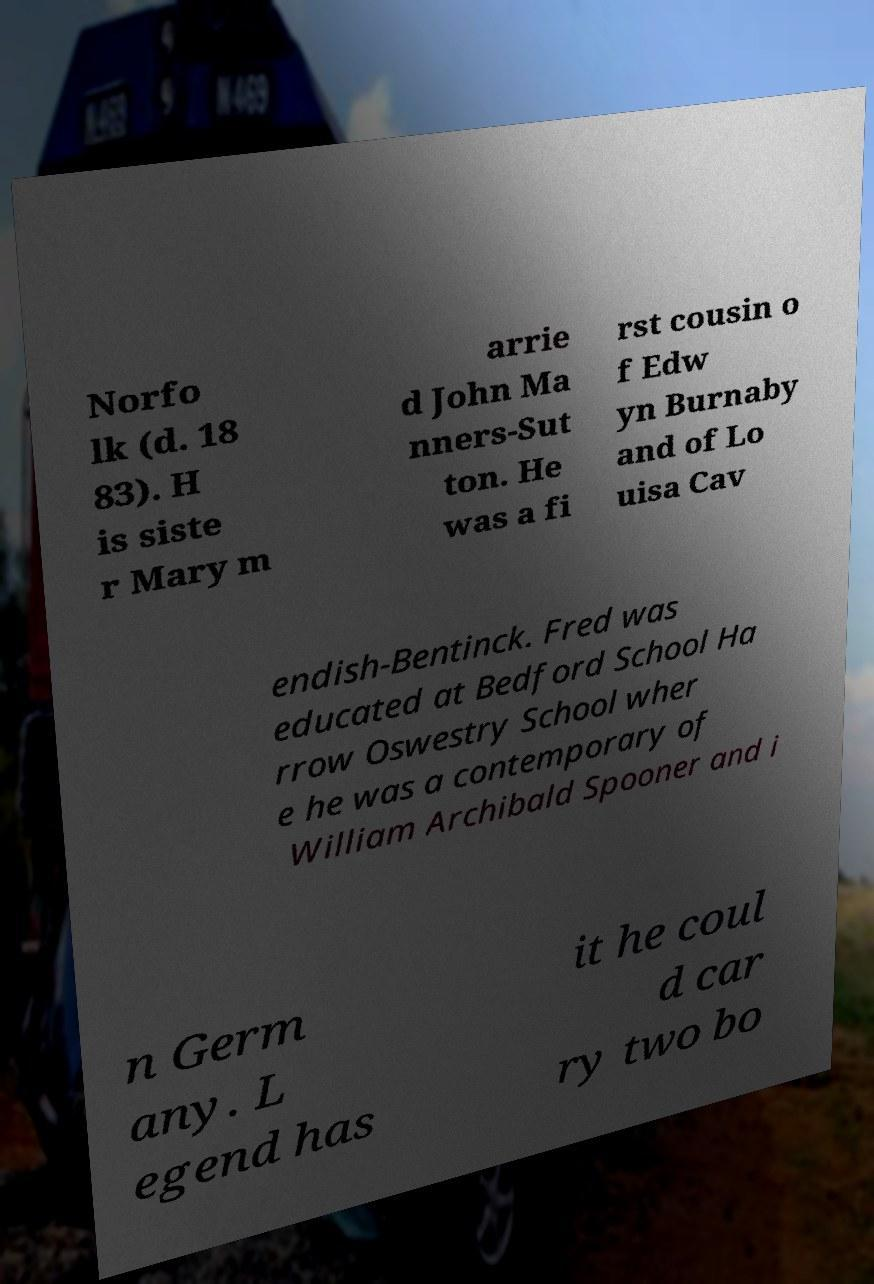Can you read and provide the text displayed in the image?This photo seems to have some interesting text. Can you extract and type it out for me? Norfo lk (d. 18 83). H is siste r Mary m arrie d John Ma nners-Sut ton. He was a fi rst cousin o f Edw yn Burnaby and of Lo uisa Cav endish-Bentinck. Fred was educated at Bedford School Ha rrow Oswestry School wher e he was a contemporary of William Archibald Spooner and i n Germ any. L egend has it he coul d car ry two bo 